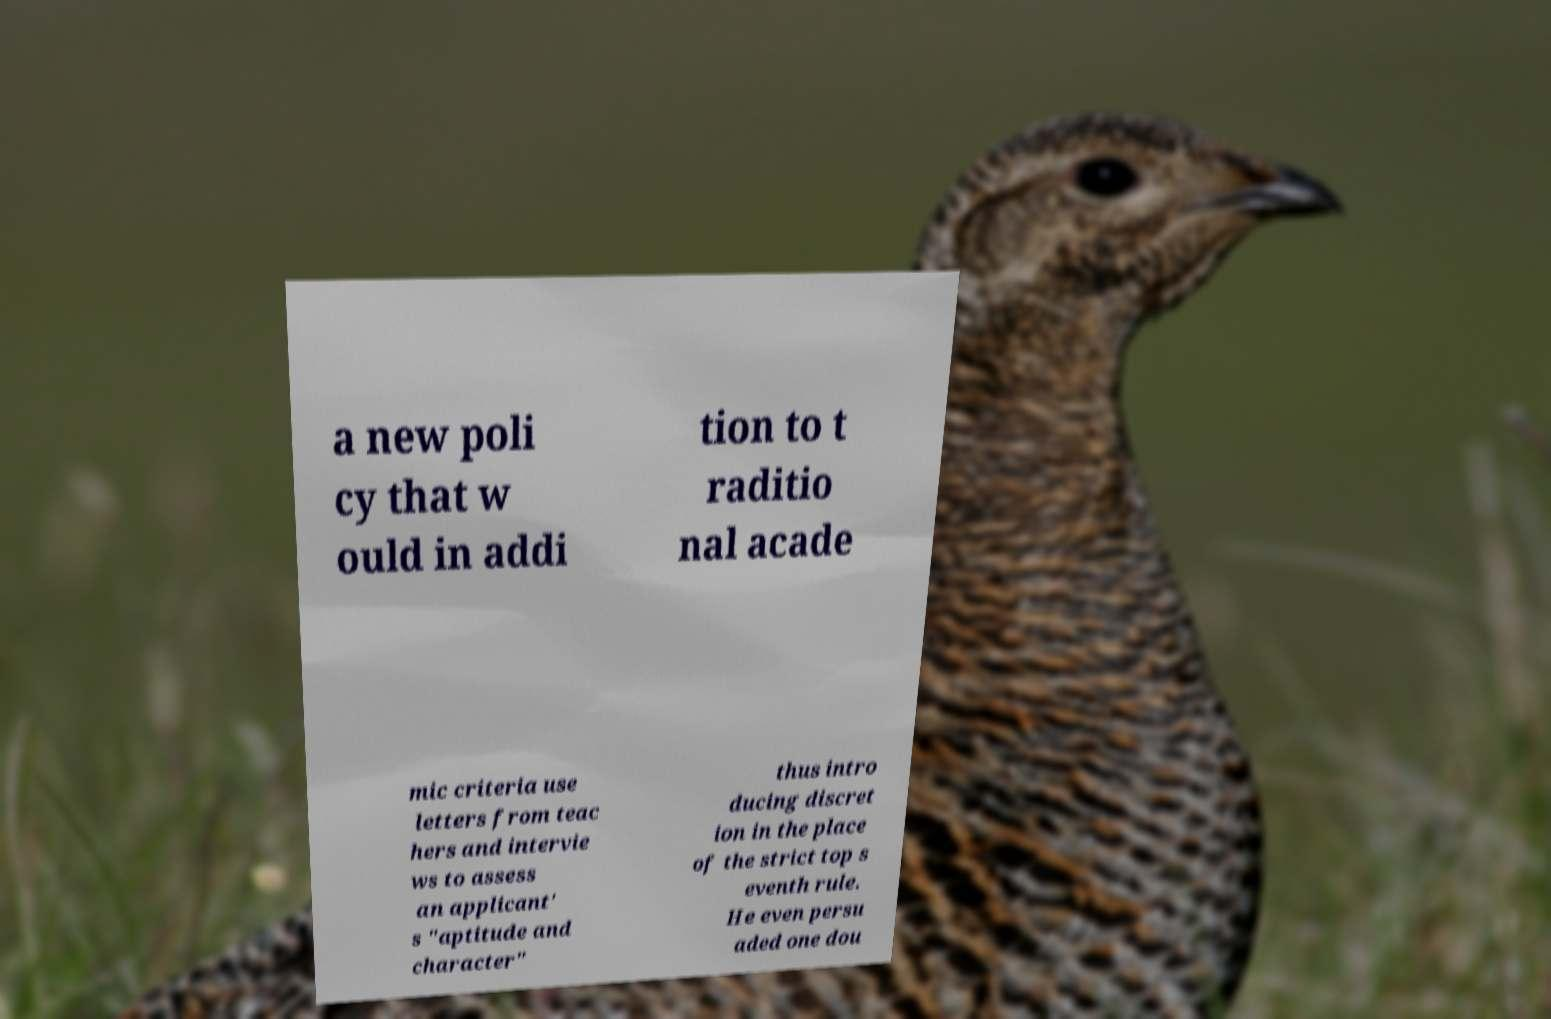Could you extract and type out the text from this image? a new poli cy that w ould in addi tion to t raditio nal acade mic criteria use letters from teac hers and intervie ws to assess an applicant' s "aptitude and character" thus intro ducing discret ion in the place of the strict top s eventh rule. He even persu aded one dou 